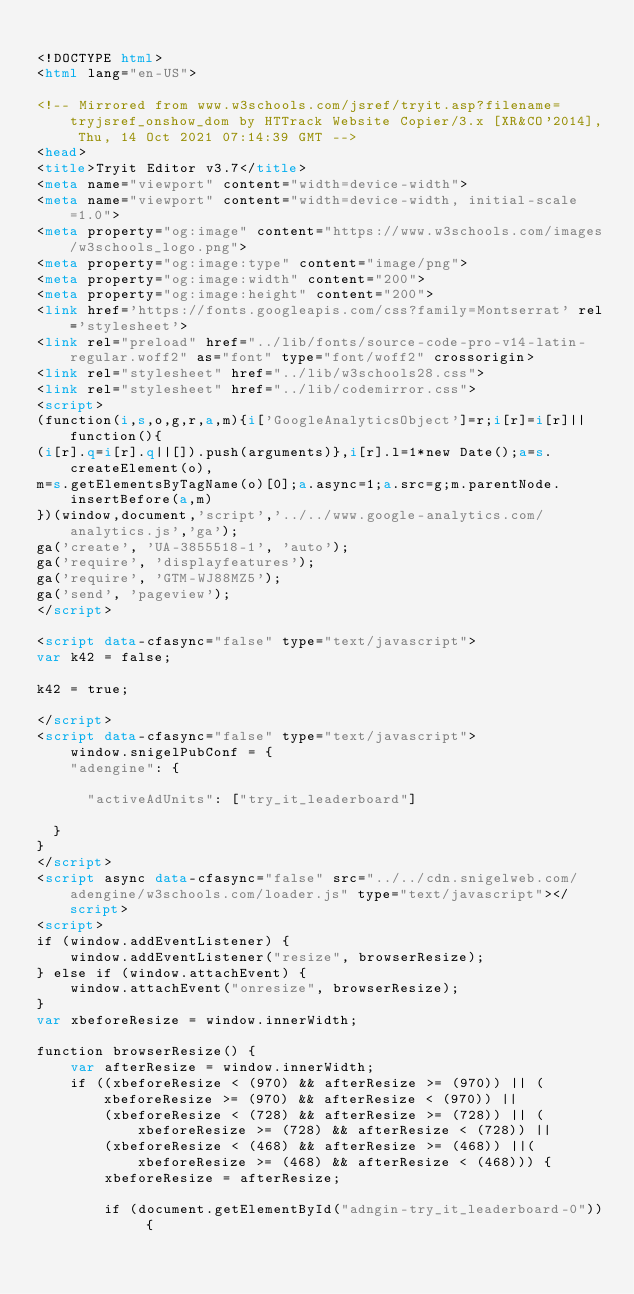<code> <loc_0><loc_0><loc_500><loc_500><_HTML_>
<!DOCTYPE html>
<html lang="en-US">

<!-- Mirrored from www.w3schools.com/jsref/tryit.asp?filename=tryjsref_onshow_dom by HTTrack Website Copier/3.x [XR&CO'2014], Thu, 14 Oct 2021 07:14:39 GMT -->
<head>
<title>Tryit Editor v3.7</title>
<meta name="viewport" content="width=device-width">
<meta name="viewport" content="width=device-width, initial-scale=1.0">
<meta property="og:image" content="https://www.w3schools.com/images/w3schools_logo.png">
<meta property="og:image:type" content="image/png">
<meta property="og:image:width" content="200">
<meta property="og:image:height" content="200">
<link href='https://fonts.googleapis.com/css?family=Montserrat' rel='stylesheet'>
<link rel="preload" href="../lib/fonts/source-code-pro-v14-latin-regular.woff2" as="font" type="font/woff2" crossorigin>
<link rel="stylesheet" href="../lib/w3schools28.css">
<link rel="stylesheet" href="../lib/codemirror.css">
<script>
(function(i,s,o,g,r,a,m){i['GoogleAnalyticsObject']=r;i[r]=i[r]||function(){
(i[r].q=i[r].q||[]).push(arguments)},i[r].l=1*new Date();a=s.createElement(o),
m=s.getElementsByTagName(o)[0];a.async=1;a.src=g;m.parentNode.insertBefore(a,m)
})(window,document,'script','../../www.google-analytics.com/analytics.js','ga');
ga('create', 'UA-3855518-1', 'auto');
ga('require', 'displayfeatures');
ga('require', 'GTM-WJ88MZ5');
ga('send', 'pageview');
</script>

<script data-cfasync="false" type="text/javascript">
var k42 = false;

k42 = true;

</script>
<script data-cfasync="false" type="text/javascript">
    window.snigelPubConf = {
    "adengine": {

      "activeAdUnits": ["try_it_leaderboard"]

  }
}
</script>
<script async data-cfasync="false" src="../../cdn.snigelweb.com/adengine/w3schools.com/loader.js" type="text/javascript"></script>
<script>
if (window.addEventListener) {              
    window.addEventListener("resize", browserResize);
} else if (window.attachEvent) {                 
    window.attachEvent("onresize", browserResize);
}
var xbeforeResize = window.innerWidth;

function browserResize() {
    var afterResize = window.innerWidth;
    if ((xbeforeResize < (970) && afterResize >= (970)) || (xbeforeResize >= (970) && afterResize < (970)) ||
        (xbeforeResize < (728) && afterResize >= (728)) || (xbeforeResize >= (728) && afterResize < (728)) ||
        (xbeforeResize < (468) && afterResize >= (468)) ||(xbeforeResize >= (468) && afterResize < (468))) {
        xbeforeResize = afterResize;
        
        if (document.getElementById("adngin-try_it_leaderboard-0")) {</code> 